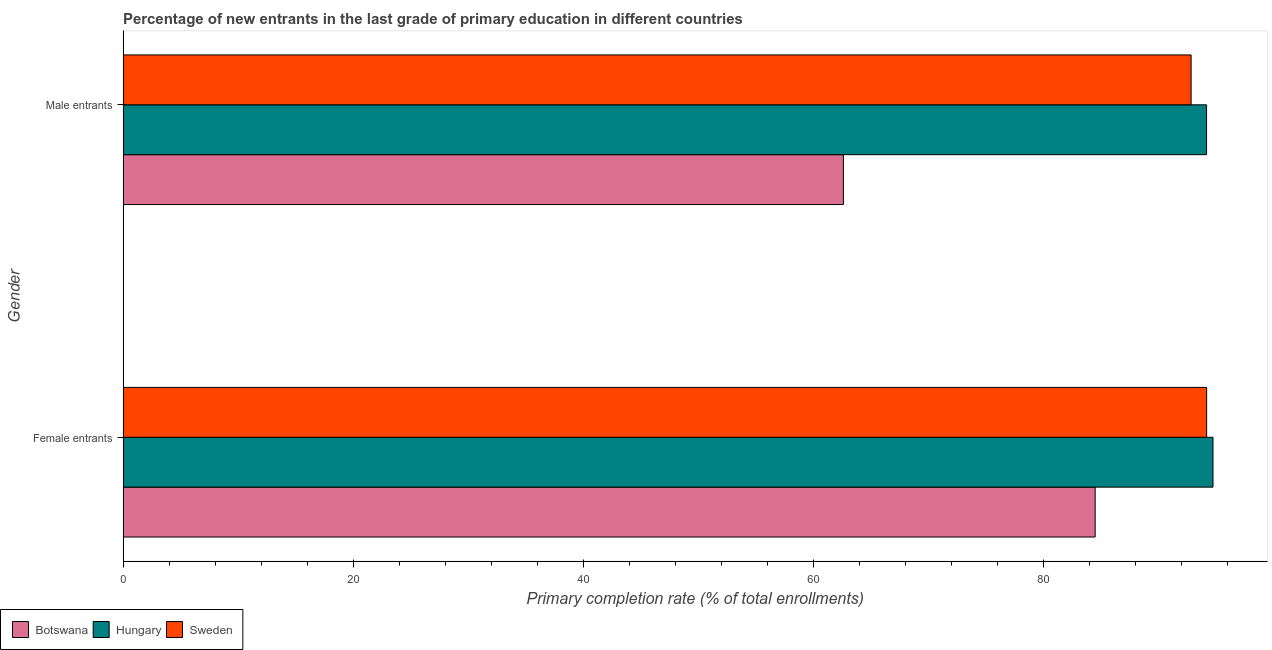How many groups of bars are there?
Offer a terse response. 2. Are the number of bars per tick equal to the number of legend labels?
Offer a very short reply. Yes. Are the number of bars on each tick of the Y-axis equal?
Provide a short and direct response. Yes. How many bars are there on the 2nd tick from the bottom?
Provide a succinct answer. 3. What is the label of the 2nd group of bars from the top?
Provide a succinct answer. Female entrants. What is the primary completion rate of female entrants in Botswana?
Give a very brief answer. 84.48. Across all countries, what is the maximum primary completion rate of female entrants?
Offer a very short reply. 94.72. Across all countries, what is the minimum primary completion rate of female entrants?
Make the answer very short. 84.48. In which country was the primary completion rate of female entrants maximum?
Provide a succinct answer. Hungary. In which country was the primary completion rate of male entrants minimum?
Offer a terse response. Botswana. What is the total primary completion rate of female entrants in the graph?
Give a very brief answer. 273.37. What is the difference between the primary completion rate of male entrants in Botswana and that in Hungary?
Give a very brief answer. -31.56. What is the difference between the primary completion rate of female entrants in Hungary and the primary completion rate of male entrants in Sweden?
Provide a succinct answer. 1.9. What is the average primary completion rate of female entrants per country?
Your response must be concise. 91.12. What is the difference between the primary completion rate of male entrants and primary completion rate of female entrants in Sweden?
Offer a very short reply. -1.35. In how many countries, is the primary completion rate of female entrants greater than 40 %?
Your answer should be very brief. 3. What is the ratio of the primary completion rate of male entrants in Botswana to that in Sweden?
Give a very brief answer. 0.67. Is the primary completion rate of male entrants in Botswana less than that in Sweden?
Provide a succinct answer. Yes. What does the 3rd bar from the top in Male entrants represents?
Provide a short and direct response. Botswana. Are all the bars in the graph horizontal?
Your response must be concise. Yes. How many countries are there in the graph?
Keep it short and to the point. 3. What is the difference between two consecutive major ticks on the X-axis?
Keep it short and to the point. 20. Where does the legend appear in the graph?
Give a very brief answer. Bottom left. What is the title of the graph?
Your response must be concise. Percentage of new entrants in the last grade of primary education in different countries. Does "Libya" appear as one of the legend labels in the graph?
Offer a very short reply. No. What is the label or title of the X-axis?
Provide a succinct answer. Primary completion rate (% of total enrollments). What is the Primary completion rate (% of total enrollments) in Botswana in Female entrants?
Make the answer very short. 84.48. What is the Primary completion rate (% of total enrollments) in Hungary in Female entrants?
Offer a very short reply. 94.72. What is the Primary completion rate (% of total enrollments) in Sweden in Female entrants?
Offer a very short reply. 94.17. What is the Primary completion rate (% of total enrollments) of Botswana in Male entrants?
Your response must be concise. 62.6. What is the Primary completion rate (% of total enrollments) of Hungary in Male entrants?
Offer a terse response. 94.16. What is the Primary completion rate (% of total enrollments) of Sweden in Male entrants?
Provide a short and direct response. 92.82. Across all Gender, what is the maximum Primary completion rate (% of total enrollments) of Botswana?
Ensure brevity in your answer.  84.48. Across all Gender, what is the maximum Primary completion rate (% of total enrollments) of Hungary?
Make the answer very short. 94.72. Across all Gender, what is the maximum Primary completion rate (% of total enrollments) of Sweden?
Give a very brief answer. 94.17. Across all Gender, what is the minimum Primary completion rate (% of total enrollments) in Botswana?
Your answer should be compact. 62.6. Across all Gender, what is the minimum Primary completion rate (% of total enrollments) of Hungary?
Your answer should be very brief. 94.16. Across all Gender, what is the minimum Primary completion rate (% of total enrollments) in Sweden?
Offer a very short reply. 92.82. What is the total Primary completion rate (% of total enrollments) of Botswana in the graph?
Your answer should be very brief. 147.08. What is the total Primary completion rate (% of total enrollments) in Hungary in the graph?
Provide a short and direct response. 188.89. What is the total Primary completion rate (% of total enrollments) in Sweden in the graph?
Make the answer very short. 186.99. What is the difference between the Primary completion rate (% of total enrollments) of Botswana in Female entrants and that in Male entrants?
Your answer should be compact. 21.88. What is the difference between the Primary completion rate (% of total enrollments) in Hungary in Female entrants and that in Male entrants?
Offer a very short reply. 0.56. What is the difference between the Primary completion rate (% of total enrollments) of Sweden in Female entrants and that in Male entrants?
Offer a very short reply. 1.35. What is the difference between the Primary completion rate (% of total enrollments) of Botswana in Female entrants and the Primary completion rate (% of total enrollments) of Hungary in Male entrants?
Give a very brief answer. -9.68. What is the difference between the Primary completion rate (% of total enrollments) in Botswana in Female entrants and the Primary completion rate (% of total enrollments) in Sweden in Male entrants?
Provide a succinct answer. -8.34. What is the difference between the Primary completion rate (% of total enrollments) in Hungary in Female entrants and the Primary completion rate (% of total enrollments) in Sweden in Male entrants?
Your answer should be compact. 1.9. What is the average Primary completion rate (% of total enrollments) of Botswana per Gender?
Offer a very short reply. 73.54. What is the average Primary completion rate (% of total enrollments) of Hungary per Gender?
Your answer should be very brief. 94.44. What is the average Primary completion rate (% of total enrollments) of Sweden per Gender?
Offer a very short reply. 93.5. What is the difference between the Primary completion rate (% of total enrollments) of Botswana and Primary completion rate (% of total enrollments) of Hungary in Female entrants?
Provide a succinct answer. -10.24. What is the difference between the Primary completion rate (% of total enrollments) in Botswana and Primary completion rate (% of total enrollments) in Sweden in Female entrants?
Offer a very short reply. -9.69. What is the difference between the Primary completion rate (% of total enrollments) in Hungary and Primary completion rate (% of total enrollments) in Sweden in Female entrants?
Provide a succinct answer. 0.55. What is the difference between the Primary completion rate (% of total enrollments) in Botswana and Primary completion rate (% of total enrollments) in Hungary in Male entrants?
Your answer should be very brief. -31.56. What is the difference between the Primary completion rate (% of total enrollments) in Botswana and Primary completion rate (% of total enrollments) in Sweden in Male entrants?
Provide a short and direct response. -30.22. What is the difference between the Primary completion rate (% of total enrollments) in Hungary and Primary completion rate (% of total enrollments) in Sweden in Male entrants?
Keep it short and to the point. 1.34. What is the ratio of the Primary completion rate (% of total enrollments) of Botswana in Female entrants to that in Male entrants?
Provide a succinct answer. 1.35. What is the ratio of the Primary completion rate (% of total enrollments) in Hungary in Female entrants to that in Male entrants?
Your answer should be compact. 1.01. What is the ratio of the Primary completion rate (% of total enrollments) in Sweden in Female entrants to that in Male entrants?
Provide a short and direct response. 1.01. What is the difference between the highest and the second highest Primary completion rate (% of total enrollments) in Botswana?
Offer a very short reply. 21.88. What is the difference between the highest and the second highest Primary completion rate (% of total enrollments) in Hungary?
Ensure brevity in your answer.  0.56. What is the difference between the highest and the second highest Primary completion rate (% of total enrollments) in Sweden?
Your answer should be compact. 1.35. What is the difference between the highest and the lowest Primary completion rate (% of total enrollments) of Botswana?
Your answer should be compact. 21.88. What is the difference between the highest and the lowest Primary completion rate (% of total enrollments) of Hungary?
Provide a short and direct response. 0.56. What is the difference between the highest and the lowest Primary completion rate (% of total enrollments) of Sweden?
Offer a terse response. 1.35. 